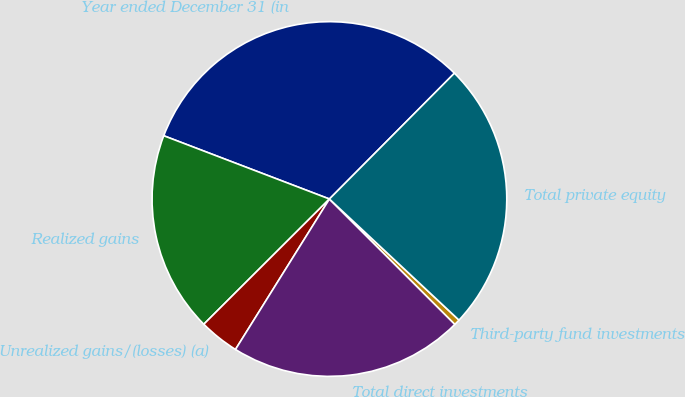Convert chart to OTSL. <chart><loc_0><loc_0><loc_500><loc_500><pie_chart><fcel>Year ended December 31 (in<fcel>Realized gains<fcel>Unrealized gains/(losses) (a)<fcel>Total direct investments<fcel>Third-party fund investments<fcel>Total private equity<nl><fcel>31.64%<fcel>18.28%<fcel>3.64%<fcel>21.39%<fcel>0.53%<fcel>24.51%<nl></chart> 